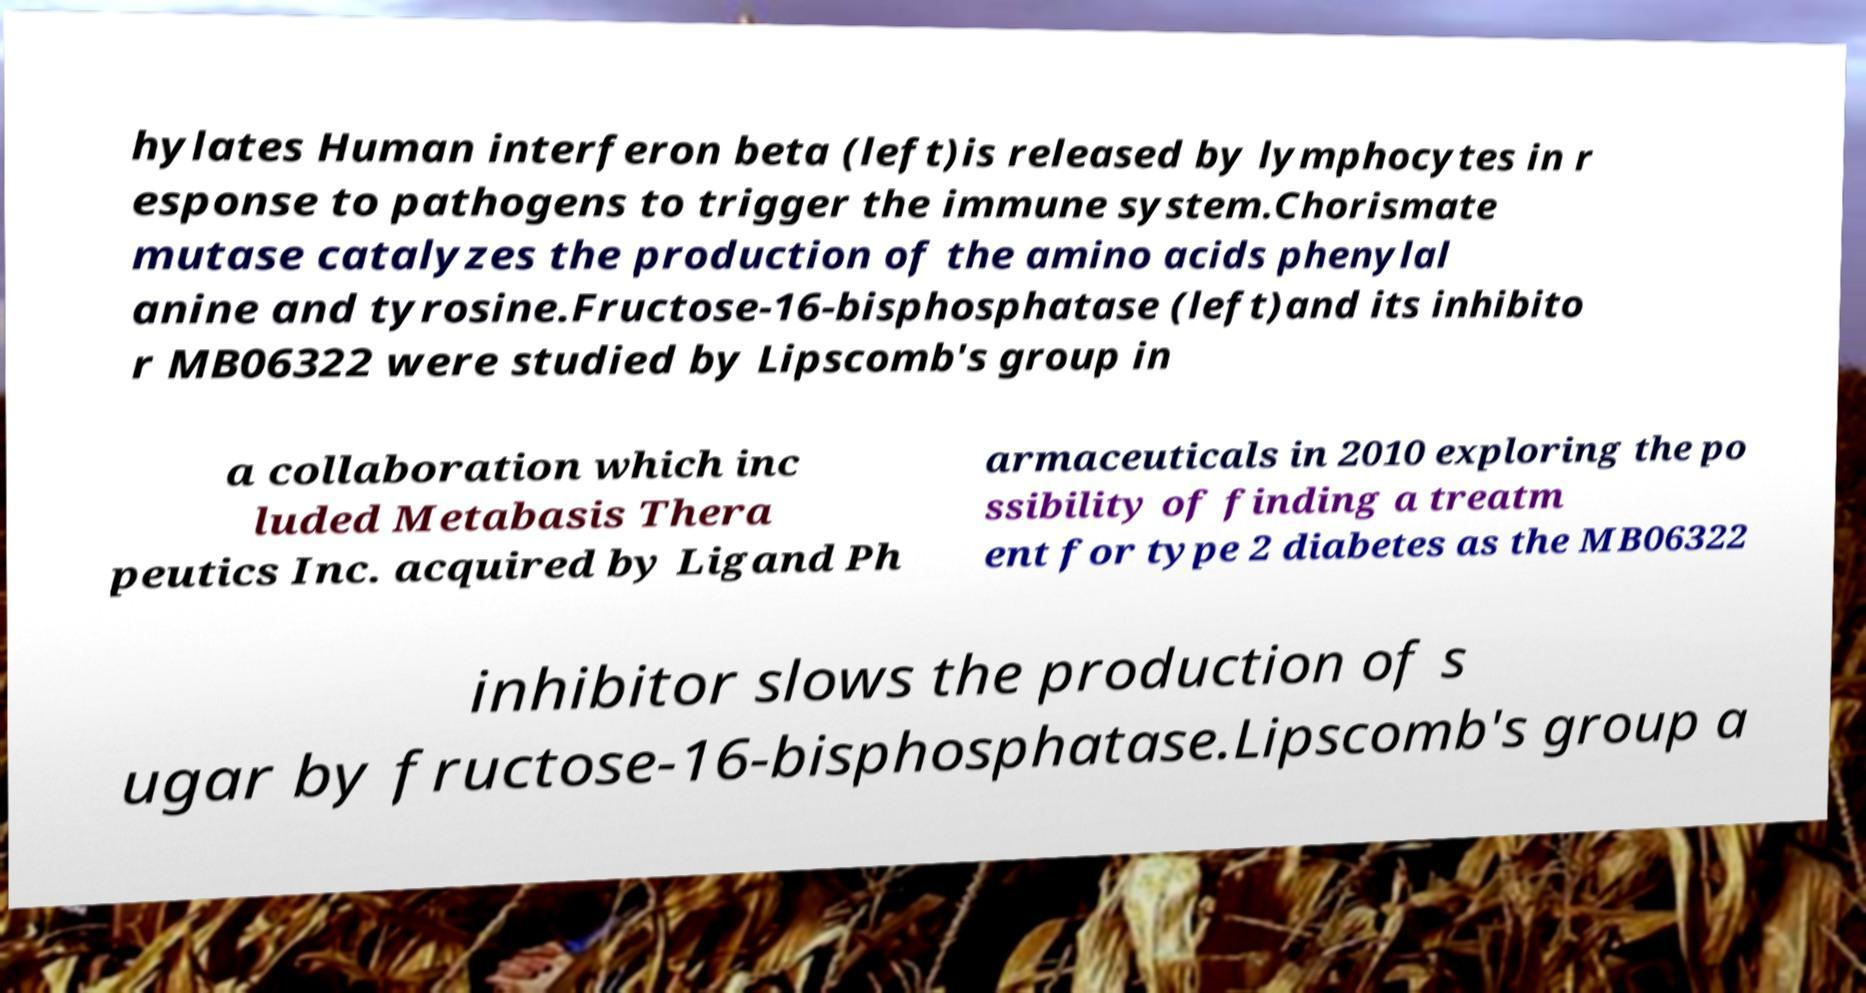What messages or text are displayed in this image? I need them in a readable, typed format. hylates Human interferon beta (left)is released by lymphocytes in r esponse to pathogens to trigger the immune system.Chorismate mutase catalyzes the production of the amino acids phenylal anine and tyrosine.Fructose-16-bisphosphatase (left)and its inhibito r MB06322 were studied by Lipscomb's group in a collaboration which inc luded Metabasis Thera peutics Inc. acquired by Ligand Ph armaceuticals in 2010 exploring the po ssibility of finding a treatm ent for type 2 diabetes as the MB06322 inhibitor slows the production of s ugar by fructose-16-bisphosphatase.Lipscomb's group a 